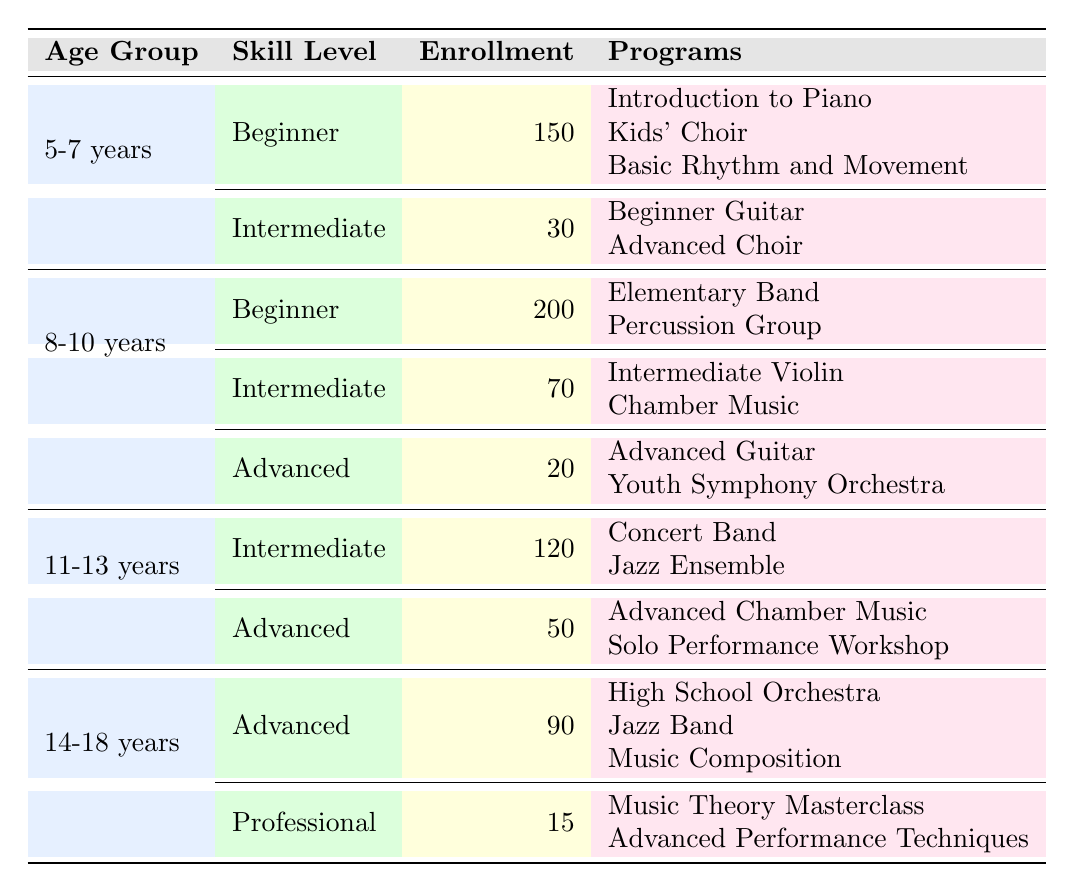What is the total enrollment for the age group 5-7 years? To find the total enrollment for the 5-7 age group, we need to add the enrollment counts of the Beginner and Intermediate skill levels. This is calculated as follows: 150 (Beginner) + 30 (Intermediate) = 180.
Answer: 180 How many different programs are offered for the Intermediate skill level in the age group 8-10 years? In the age group 8-10 years, the Intermediate skill level offers two programs: Intermediate Violin and Chamber Music. Therefore, the count of different programs is 2.
Answer: 2 Is there a Professional skill level offered for the age group 5-7 years? The table shows no Professional skill level under the 5-7 years age group; it only lists Beginner and Intermediate skill levels. Thus, the answer is no.
Answer: No What is the enrollment for the Advanced skill level in the age group 14-18 years? The Advanced skill level enrollment in the age group 14-18 years is listed as 90.
Answer: 90 What is the total enrollment for all skill levels in the age group 11-13 years? To find the total enrollment for the 11-13 years age group, we add the enrollment counts for both Intermediate and Advanced skill levels: 120 (Intermediate) + 50 (Advanced) = 170.
Answer: 170 How many programs are available at the Beginner skill level for the age group 8-10 years? In the 8-10 years age group at the Beginner skill level, there are two programs: Elementary Band and Percussion Group. So, the answer is 2.
Answer: 2 Which age group has the highest total enrollment across all skill levels? First, we sum the total enrollment for each age group: 5-7 years (180), 8-10 years (290), 11-13 years (170), and 14-18 years (105). The highest total is 290 for the 8-10 years age group.
Answer: 8-10 years Are there any Advanced skill level programs offered for children aged 5-7 years? The entries for the 5-7 years age group show only Beginner and Intermediate skill levels, without any Advanced listings. Hence, the answer is no.
Answer: No What is the difference in enrollment between Intermediate and Advanced skill levels in the 11-13 years age group? For the 11-13 years age group, the enrollment for Intermediate skill level is 120 and for Advanced, it is 50. Calculating the difference: 120 - 50 = 70.
Answer: 70 